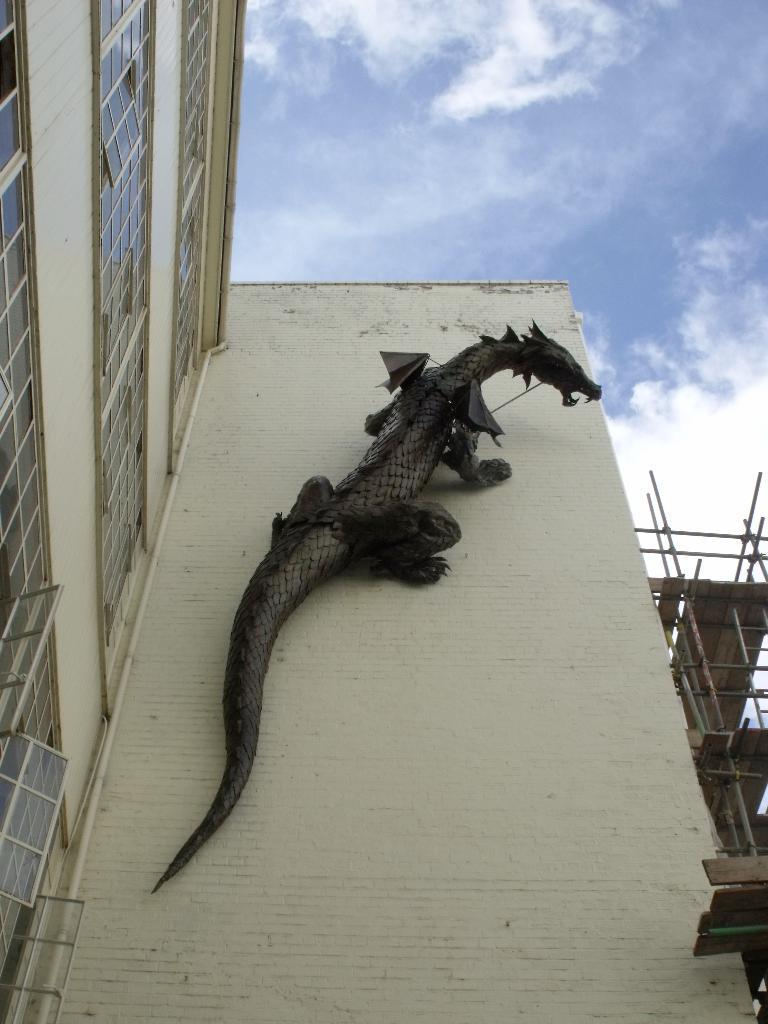Please provide a concise description of this image. In this picture I can see replica of a animal on the building and I can see under construction building on the right side and I can see blue cloudy sky. 